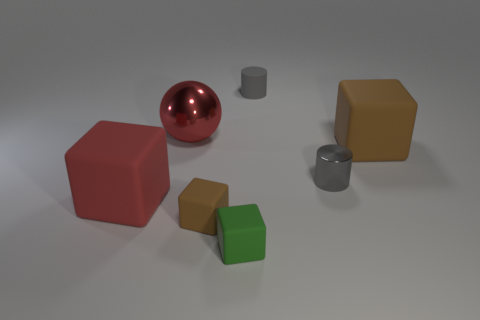Which objects in the image are the largest and the smallest by volume? The largest object by volume appears to be the orange cube, due to its overall dimensions compared to the other objects. The smallest objects are the two small gray cylinders, which have the least volume based on their size relative to the surrounding items. 